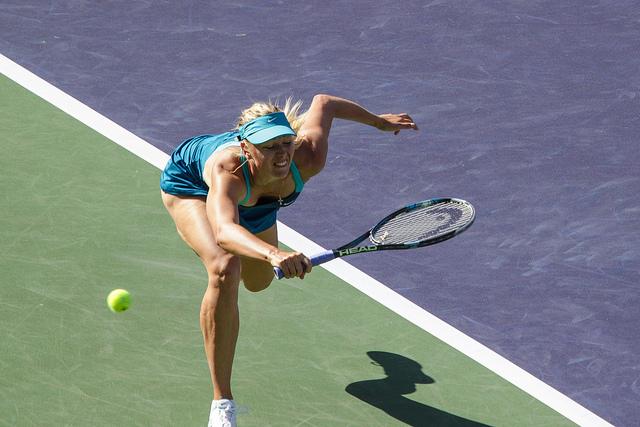Can the sun get in her eyes?
Be succinct. No. Is the lady going to fall?
Short answer required. No. What color are the woman's shoes?
Give a very brief answer. White. 